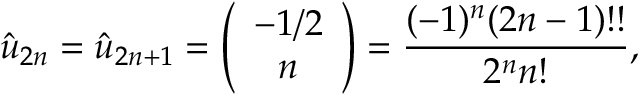Convert formula to latex. <formula><loc_0><loc_0><loc_500><loc_500>\hat { u } _ { 2 n } = \hat { u } _ { 2 n + 1 } = \left ( \begin{array} { c } { - 1 / 2 } \\ { n } \end{array} \right ) = { \frac { ( - 1 ) ^ { n } ( 2 n - 1 ) ! ! } { 2 ^ { n } n ! } } ,</formula> 